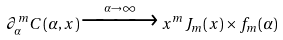Convert formula to latex. <formula><loc_0><loc_0><loc_500><loc_500>\partial ^ { m } _ { \alpha } C ( \alpha , x ) \xrightarrow { \alpha \to \infty } x ^ { m } J _ { m } ( x ) \times f _ { m } ( \alpha )</formula> 